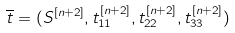Convert formula to latex. <formula><loc_0><loc_0><loc_500><loc_500>\overline { t } = ( S ^ { [ n + 2 ] } , t _ { 1 1 } ^ { [ n + 2 ] } , t _ { 2 2 } ^ { [ n + 2 ] } , t _ { 3 3 } ^ { [ n + 2 ] } )</formula> 